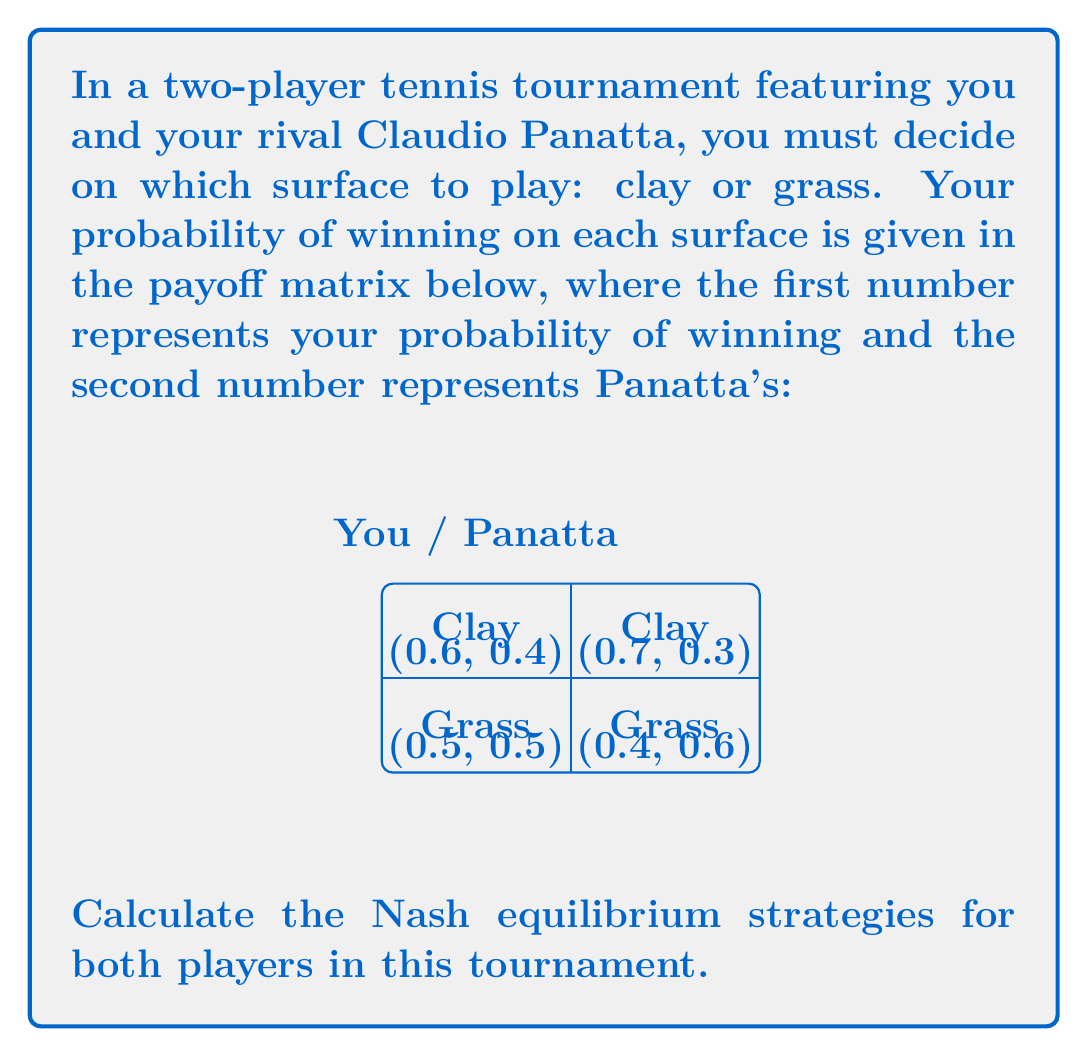Solve this math problem. To find the Nash equilibrium, we need to calculate the mixed strategy probabilities for both players. Let's approach this step-by-step:

1) Let $p$ be the probability that you choose Clay, and $q$ be the probability that Panatta chooses Clay.

2) Your expected payoff when Panatta chooses Clay:
   $E(\text{Clay}) = 0.6p + 0.7(1-p)$
   Your expected payoff when Panatta chooses Grass:
   $E(\text{Grass}) = 0.5p + 0.4(1-p)$

3) For mixed strategy equilibrium, these should be equal:
   $0.6p + 0.7(1-p) = 0.5p + 0.4(1-p)$

4) Solving this equation:
   $0.6p + 0.7 - 0.7p = 0.5p + 0.4 - 0.4p$
   $-0.1p + 0.7 = 0.1p + 0.4$
   $0.3 = 0.2p$
   $p = 1.5$

5) Since probabilities can't exceed 1, this means you should always choose Clay $(p=1)$.

6) Now for Panatta, his expected payoff when you choose Clay:
   $E(\text{Clay}) = 0.4q + 0.3(1-q)$
   His expected payoff when you choose Grass:
   $E(\text{Grass}) = 0.6q + 0.5(1-q)$

7) Setting these equal:
   $0.4q + 0.3(1-q) = 0.6q + 0.5(1-q)$
   $0.4q + 0.3 - 0.3q = 0.6q + 0.5 - 0.5q$
   $0.1q + 0.3 = 0.1q + 0.5$
   $0.3 = 0.5$

8) This is always false, meaning there's no mixed strategy for Panatta. He should always choose Grass $(q=0)$ to maximize his chances against your optimal strategy.

Therefore, the Nash equilibrium is (Clay, Grass) with probabilities (1, 1) for you and Panatta respectively.
Answer: (Clay, Grass) with probabilities (1, 1) 